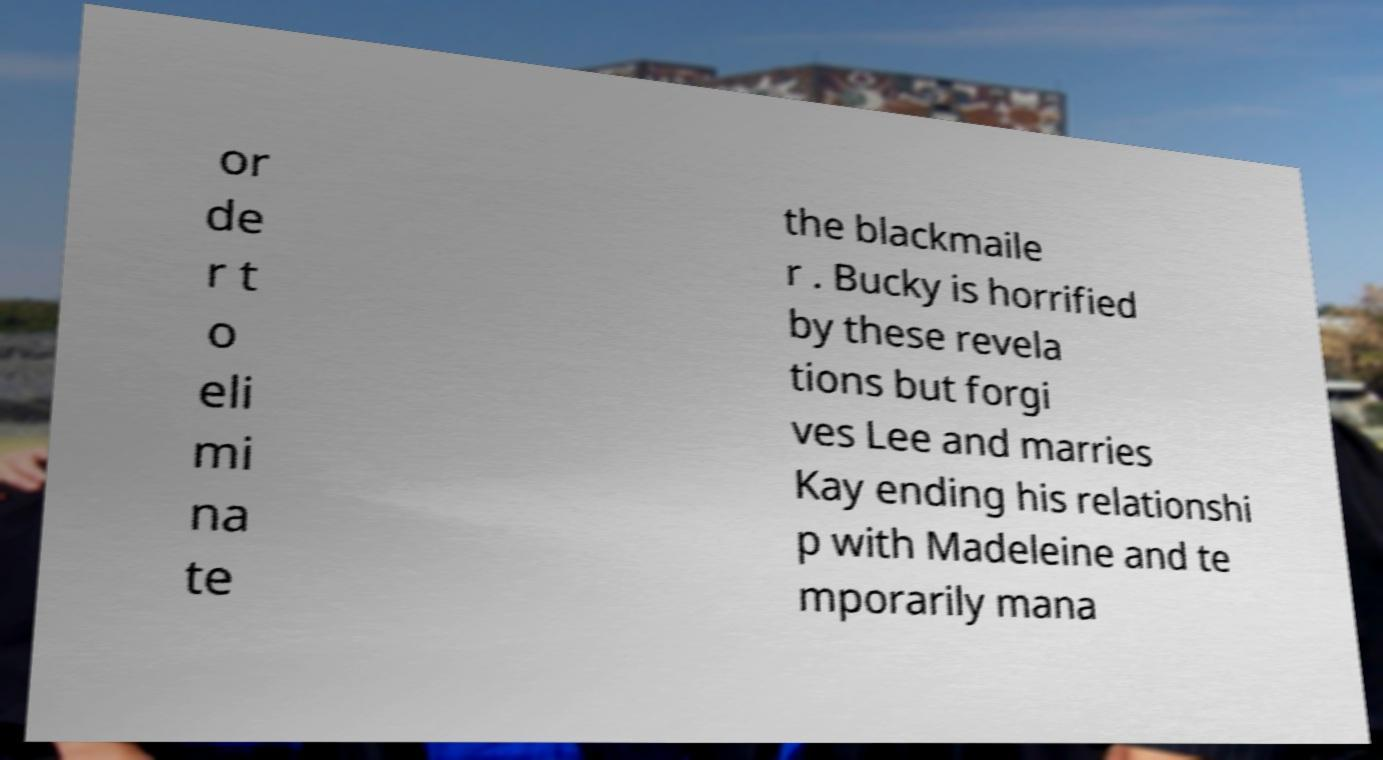I need the written content from this picture converted into text. Can you do that? or de r t o eli mi na te the blackmaile r . Bucky is horrified by these revela tions but forgi ves Lee and marries Kay ending his relationshi p with Madeleine and te mporarily mana 